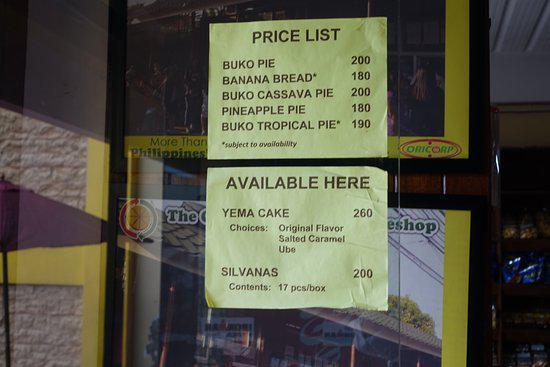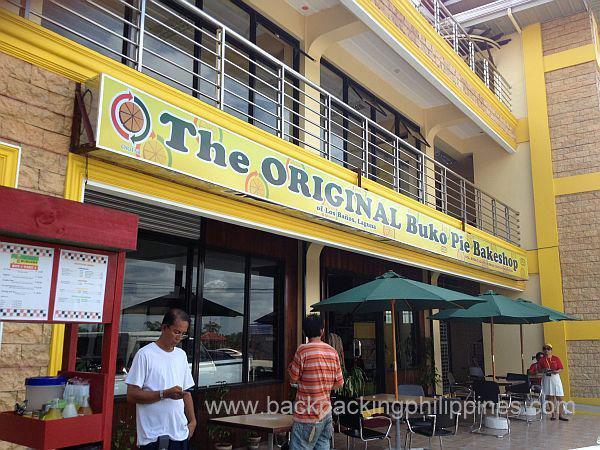The first image is the image on the left, the second image is the image on the right. Evaluate the accuracy of this statement regarding the images: "In at least one image there is a bunko pie missing at least one slice.". Is it true? Answer yes or no. No. The first image is the image on the left, the second image is the image on the right. Assess this claim about the two images: "A pie is in an open box.". Correct or not? Answer yes or no. No. 